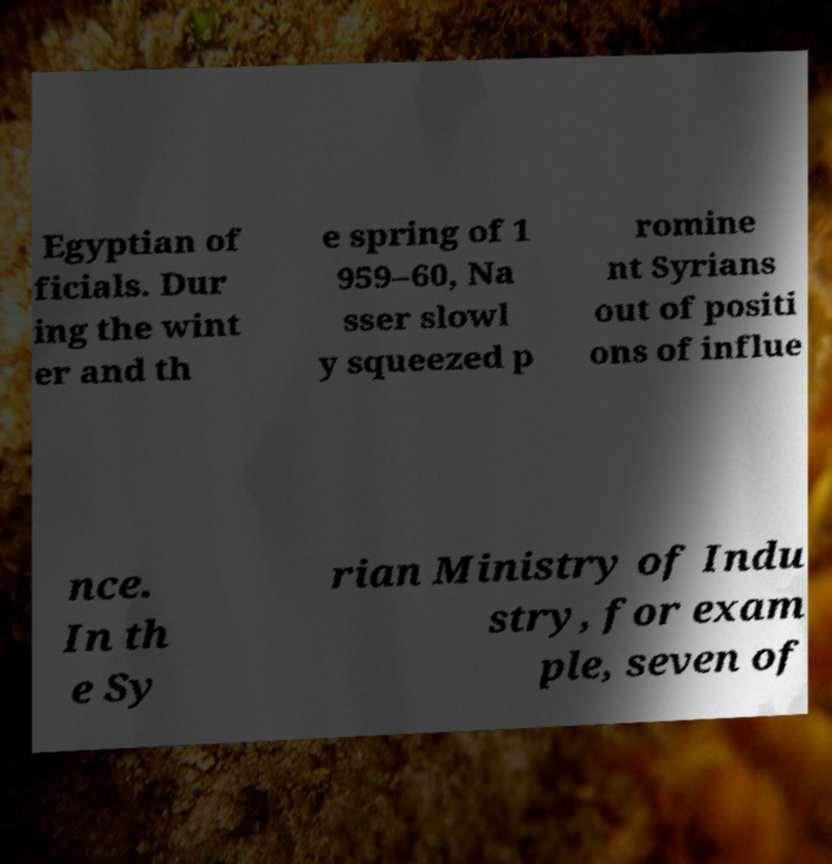Can you read and provide the text displayed in the image?This photo seems to have some interesting text. Can you extract and type it out for me? Egyptian of ficials. Dur ing the wint er and th e spring of 1 959–60, Na sser slowl y squeezed p romine nt Syrians out of positi ons of influe nce. In th e Sy rian Ministry of Indu stry, for exam ple, seven of 